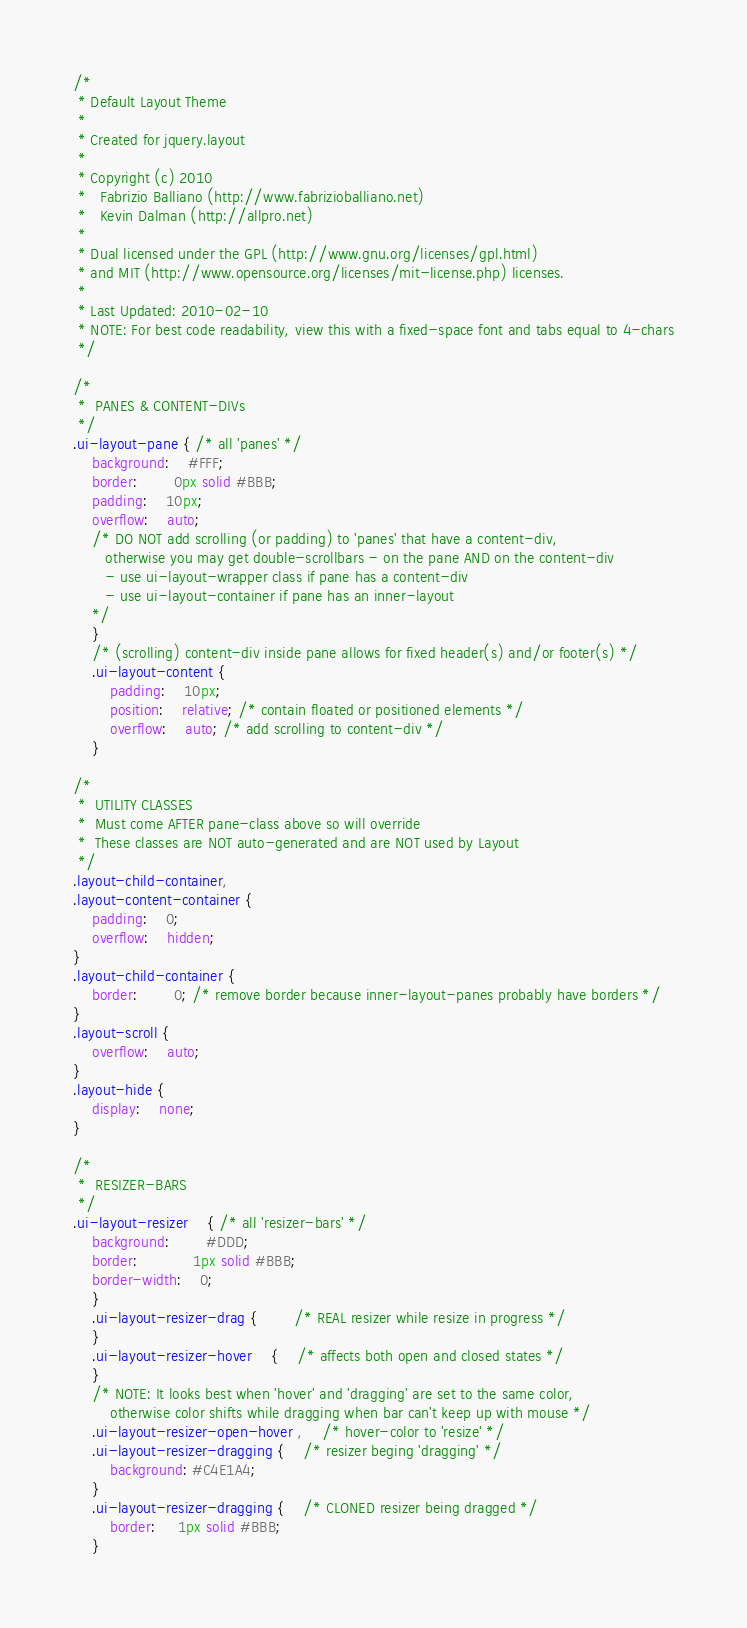<code> <loc_0><loc_0><loc_500><loc_500><_CSS_>/*
 * Default Layout Theme
 *
 * Created for jquery.layout 
 *
 * Copyright (c) 2010 
 *   Fabrizio Balliano (http://www.fabrizioballiano.net)
 *   Kevin Dalman (http://allpro.net)
 *
 * Dual licensed under the GPL (http://www.gnu.org/licenses/gpl.html)
 * and MIT (http://www.opensource.org/licenses/mit-license.php) licenses.
 *
 * Last Updated: 2010-02-10
 * NOTE: For best code readability, view this with a fixed-space font and tabs equal to 4-chars
 */

/*
 *	PANES & CONTENT-DIVs
 */
.ui-layout-pane { /* all 'panes' */
	background:	#FFF; 
	border:		0px solid #BBB;
	padding:	10px; 
	overflow:	auto;
	/* DO NOT add scrolling (or padding) to 'panes' that have a content-div,
	   otherwise you may get double-scrollbars - on the pane AND on the content-div
	   - use ui-layout-wrapper class if pane has a content-div
	   - use ui-layout-container if pane has an inner-layout
	*/
	}
	/* (scrolling) content-div inside pane allows for fixed header(s) and/or footer(s) */
	.ui-layout-content {
		padding:	10px;
		position:	relative; /* contain floated or positioned elements */
		overflow:	auto; /* add scrolling to content-div */
	}

/*
 *	UTILITY CLASSES
 *	Must come AFTER pane-class above so will override
 *	These classes are NOT auto-generated and are NOT used by Layout
 */
.layout-child-container,
.layout-content-container {
	padding:	0;
	overflow:	hidden;
}
.layout-child-container {
	border:		0; /* remove border because inner-layout-panes probably have borders */
}
.layout-scroll {
	overflow:	auto;
}
.layout-hide {
	display:	none;
}

/*
 *	RESIZER-BARS
 */
.ui-layout-resizer	{ /* all 'resizer-bars' */
	background:		#DDD;
	border:			1px solid #BBB;
	border-width:	0;
	}
	.ui-layout-resizer-drag {		/* REAL resizer while resize in progress */
	}
	.ui-layout-resizer-hover	{	/* affects both open and closed states */
	}
	/* NOTE: It looks best when 'hover' and 'dragging' are set to the same color,
		otherwise color shifts while dragging when bar can't keep up with mouse */
	.ui-layout-resizer-open-hover ,	/* hover-color to 'resize' */
	.ui-layout-resizer-dragging {	/* resizer beging 'dragging' */
		background: #C4E1A4;
	}
	.ui-layout-resizer-dragging {	/* CLONED resizer being dragged */
		border: 	 1px solid #BBB;
	}</code> 